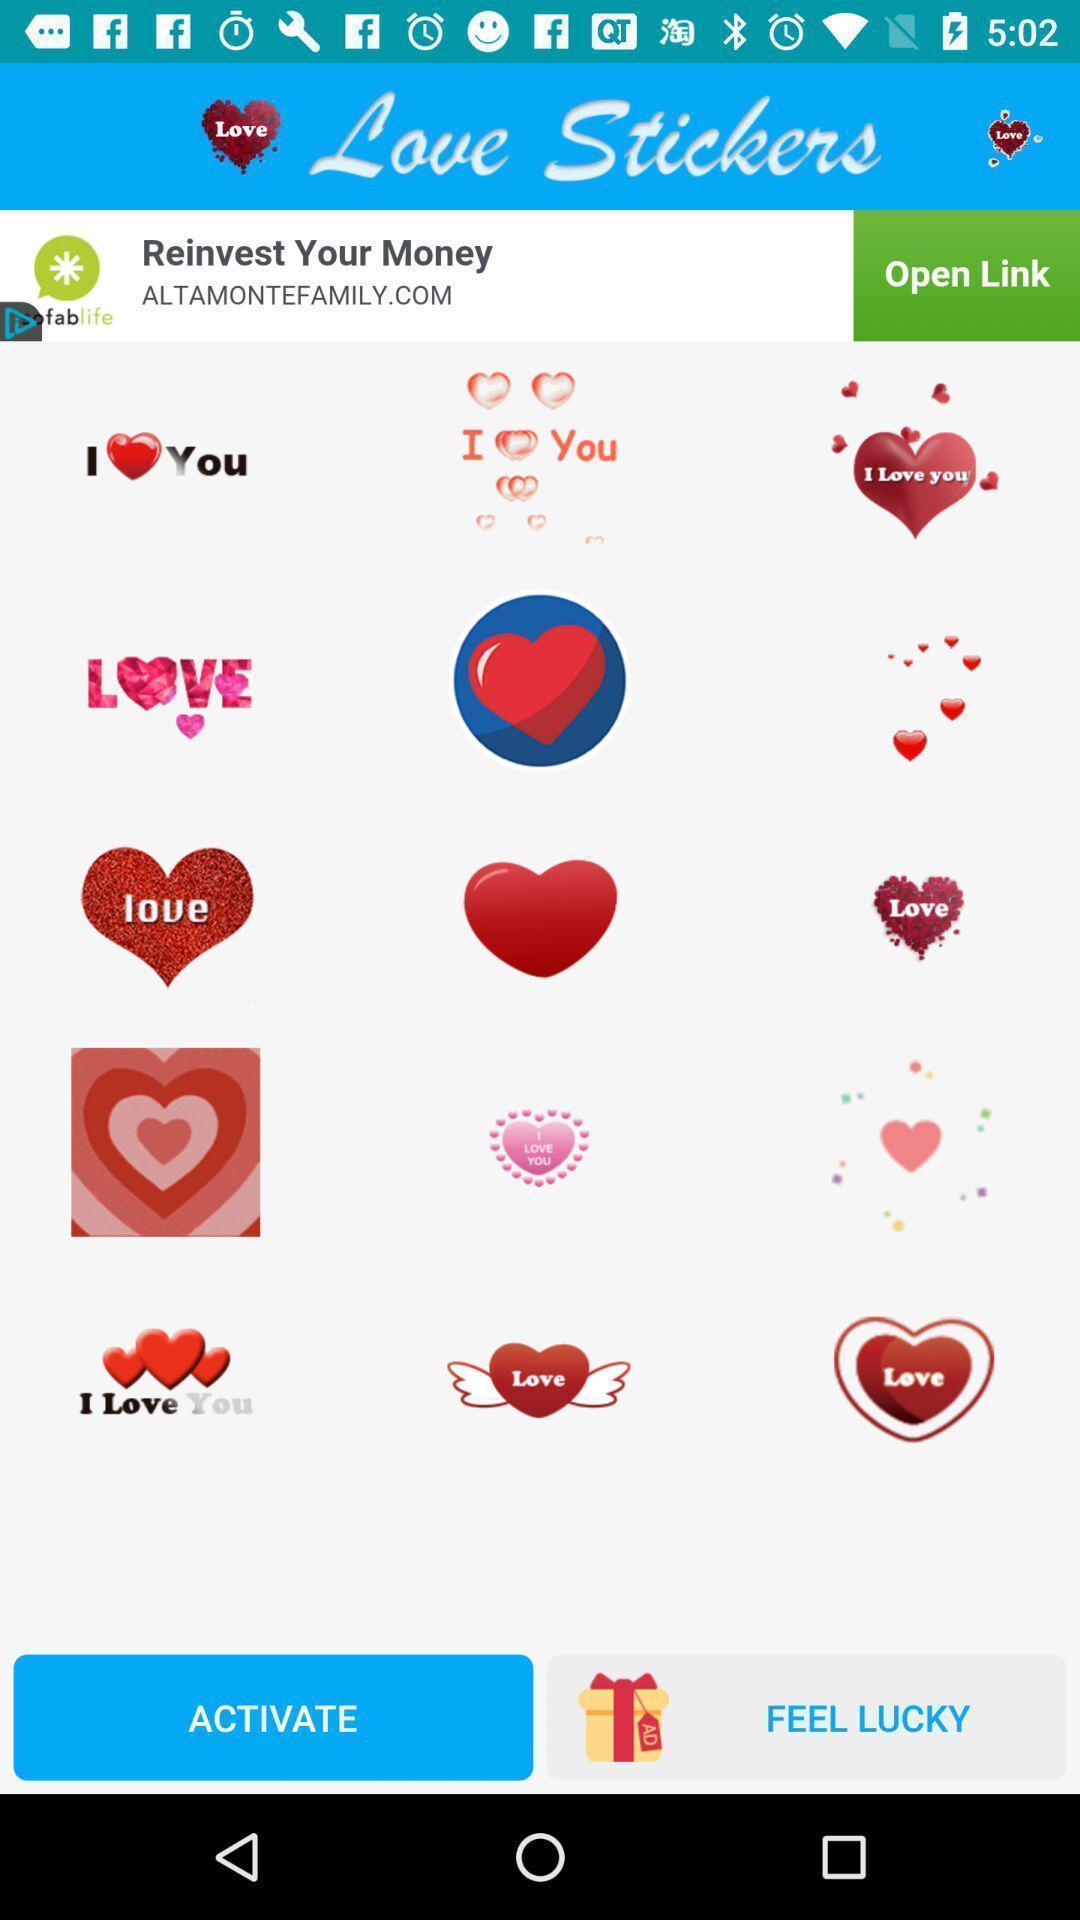What is the overall content of this screenshot? Page showing stickers to add a chat box. 